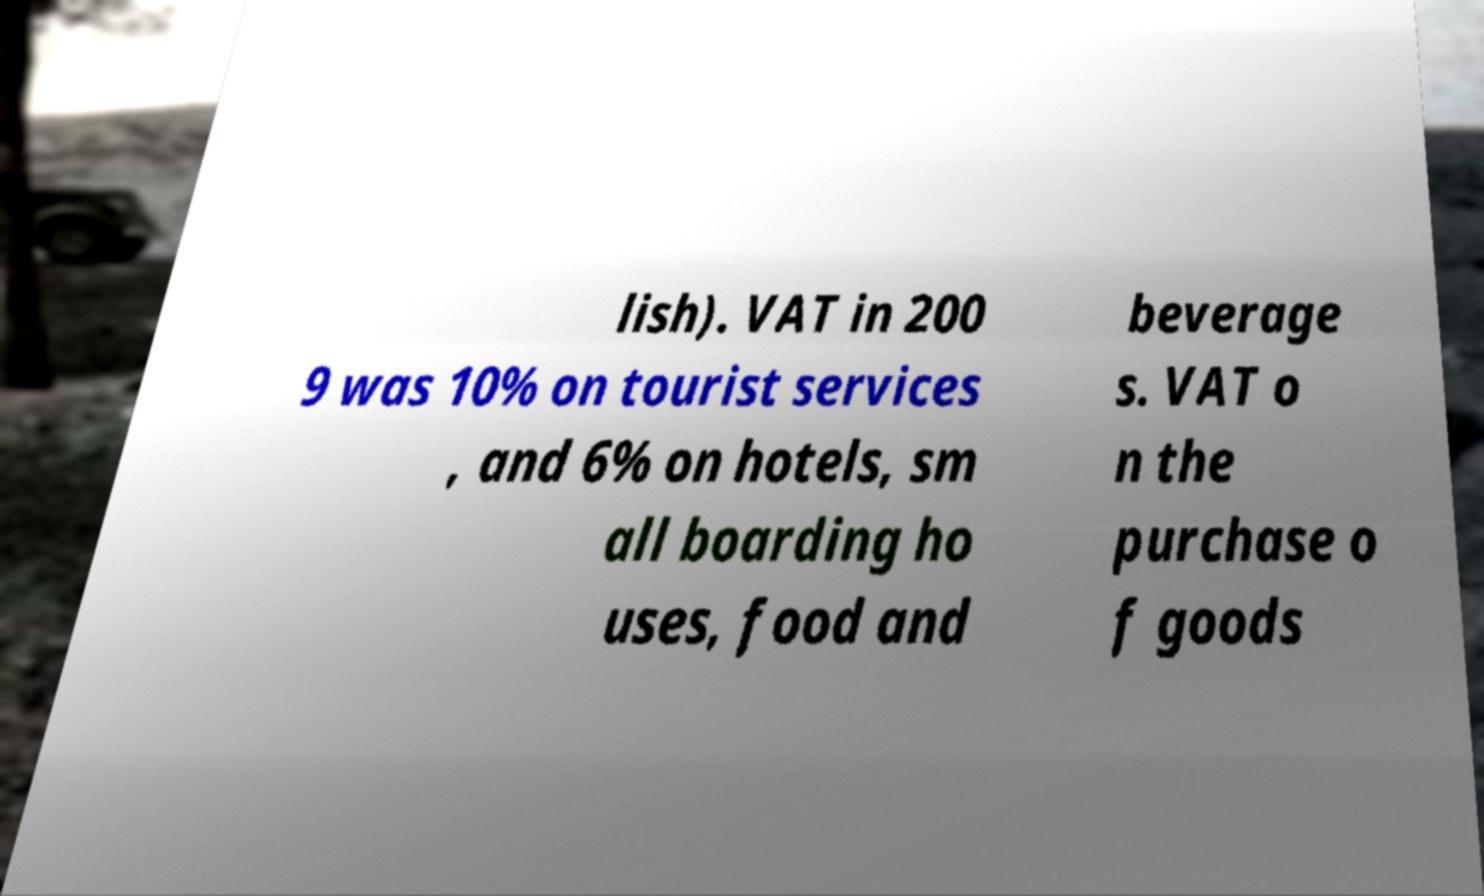For documentation purposes, I need the text within this image transcribed. Could you provide that? lish). VAT in 200 9 was 10% on tourist services , and 6% on hotels, sm all boarding ho uses, food and beverage s. VAT o n the purchase o f goods 